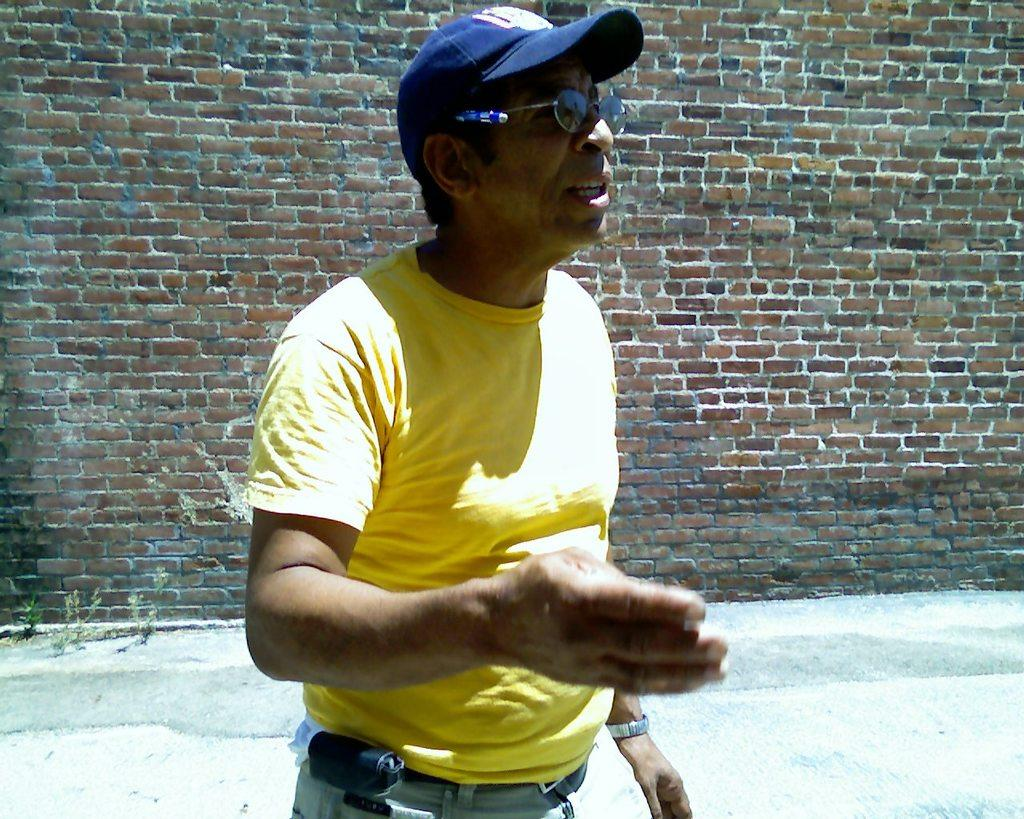What is the main subject of the image? There is a man standing in the center of the image. What is the man wearing on his head? The man is wearing a hat. What can be seen in the background of the image? There is a wall in the background of the image. What is visible at the bottom of the image? The ground is present at the bottom of the image. How many passengers are waiting at the gate in the image? There is no gate or passengers present in the image; it features a man standing in the center with a hat. What type of laborer is depicted in the image? There is no laborer depicted in the image; it features a man standing in the center with a hat. 